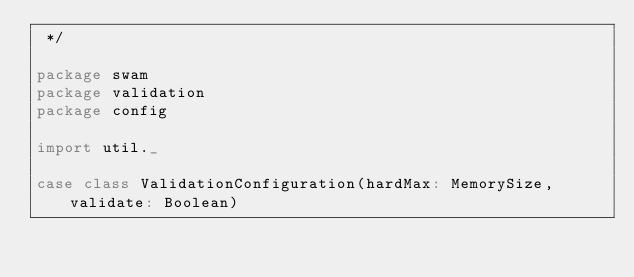<code> <loc_0><loc_0><loc_500><loc_500><_Scala_> */

package swam
package validation
package config

import util._

case class ValidationConfiguration(hardMax: MemorySize, validate: Boolean)
</code> 